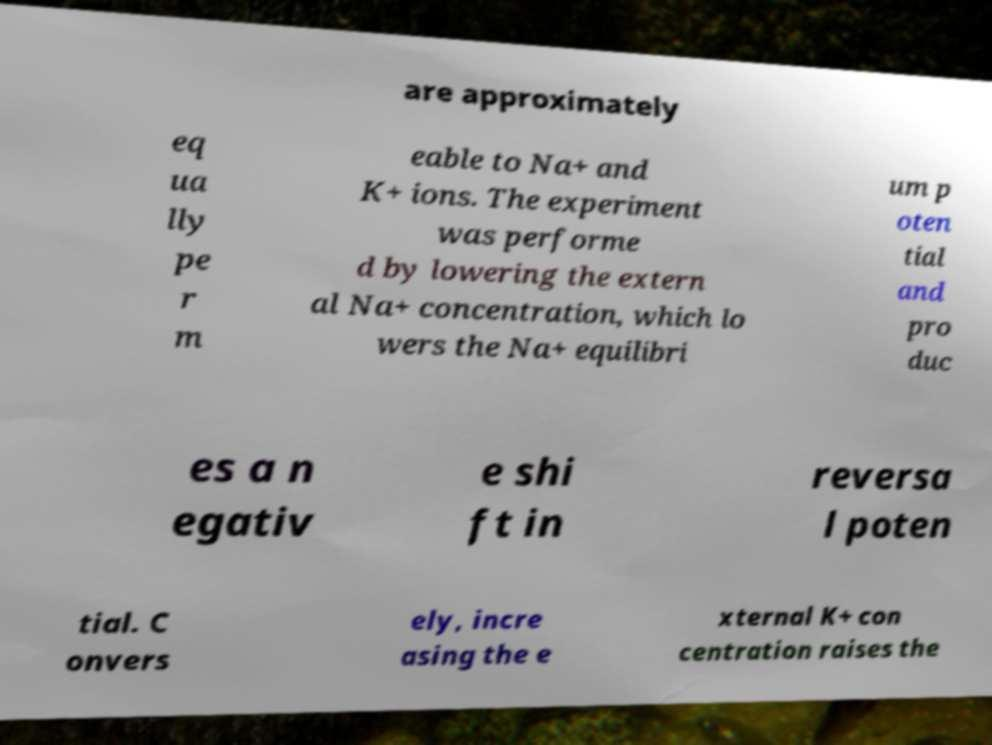Please identify and transcribe the text found in this image. are approximately eq ua lly pe r m eable to Na+ and K+ ions. The experiment was performe d by lowering the extern al Na+ concentration, which lo wers the Na+ equilibri um p oten tial and pro duc es a n egativ e shi ft in reversa l poten tial. C onvers ely, incre asing the e xternal K+ con centration raises the 